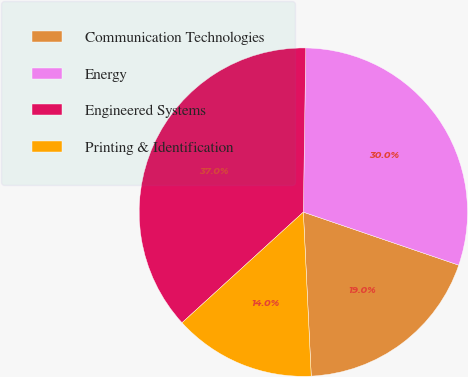Convert chart to OTSL. <chart><loc_0><loc_0><loc_500><loc_500><pie_chart><fcel>Communication Technologies<fcel>Energy<fcel>Engineered Systems<fcel>Printing & Identification<nl><fcel>19.0%<fcel>30.0%<fcel>37.0%<fcel>14.0%<nl></chart> 